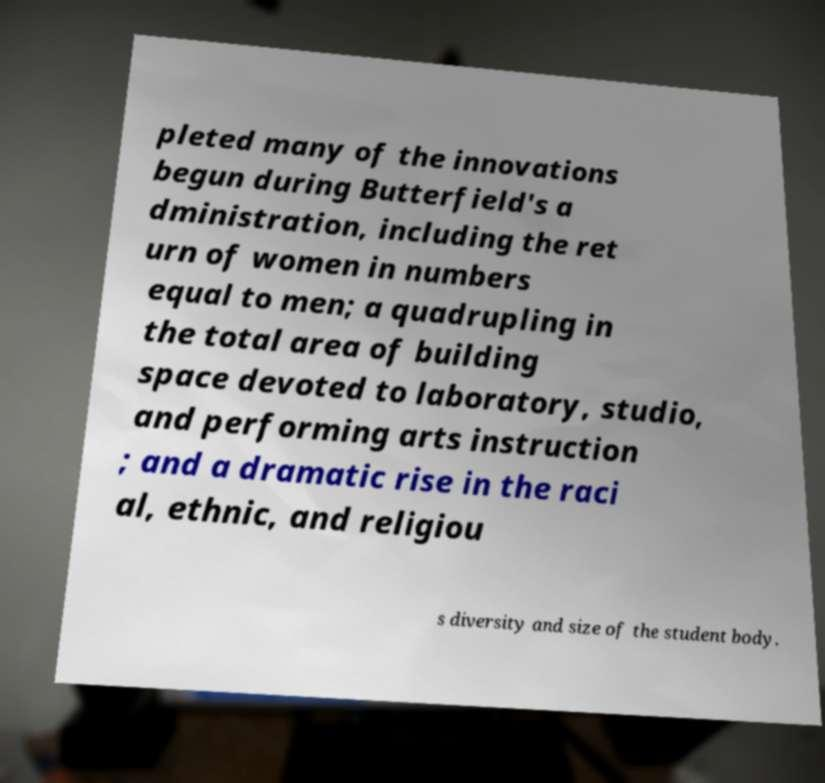For documentation purposes, I need the text within this image transcribed. Could you provide that? pleted many of the innovations begun during Butterfield's a dministration, including the ret urn of women in numbers equal to men; a quadrupling in the total area of building space devoted to laboratory, studio, and performing arts instruction ; and a dramatic rise in the raci al, ethnic, and religiou s diversity and size of the student body. 